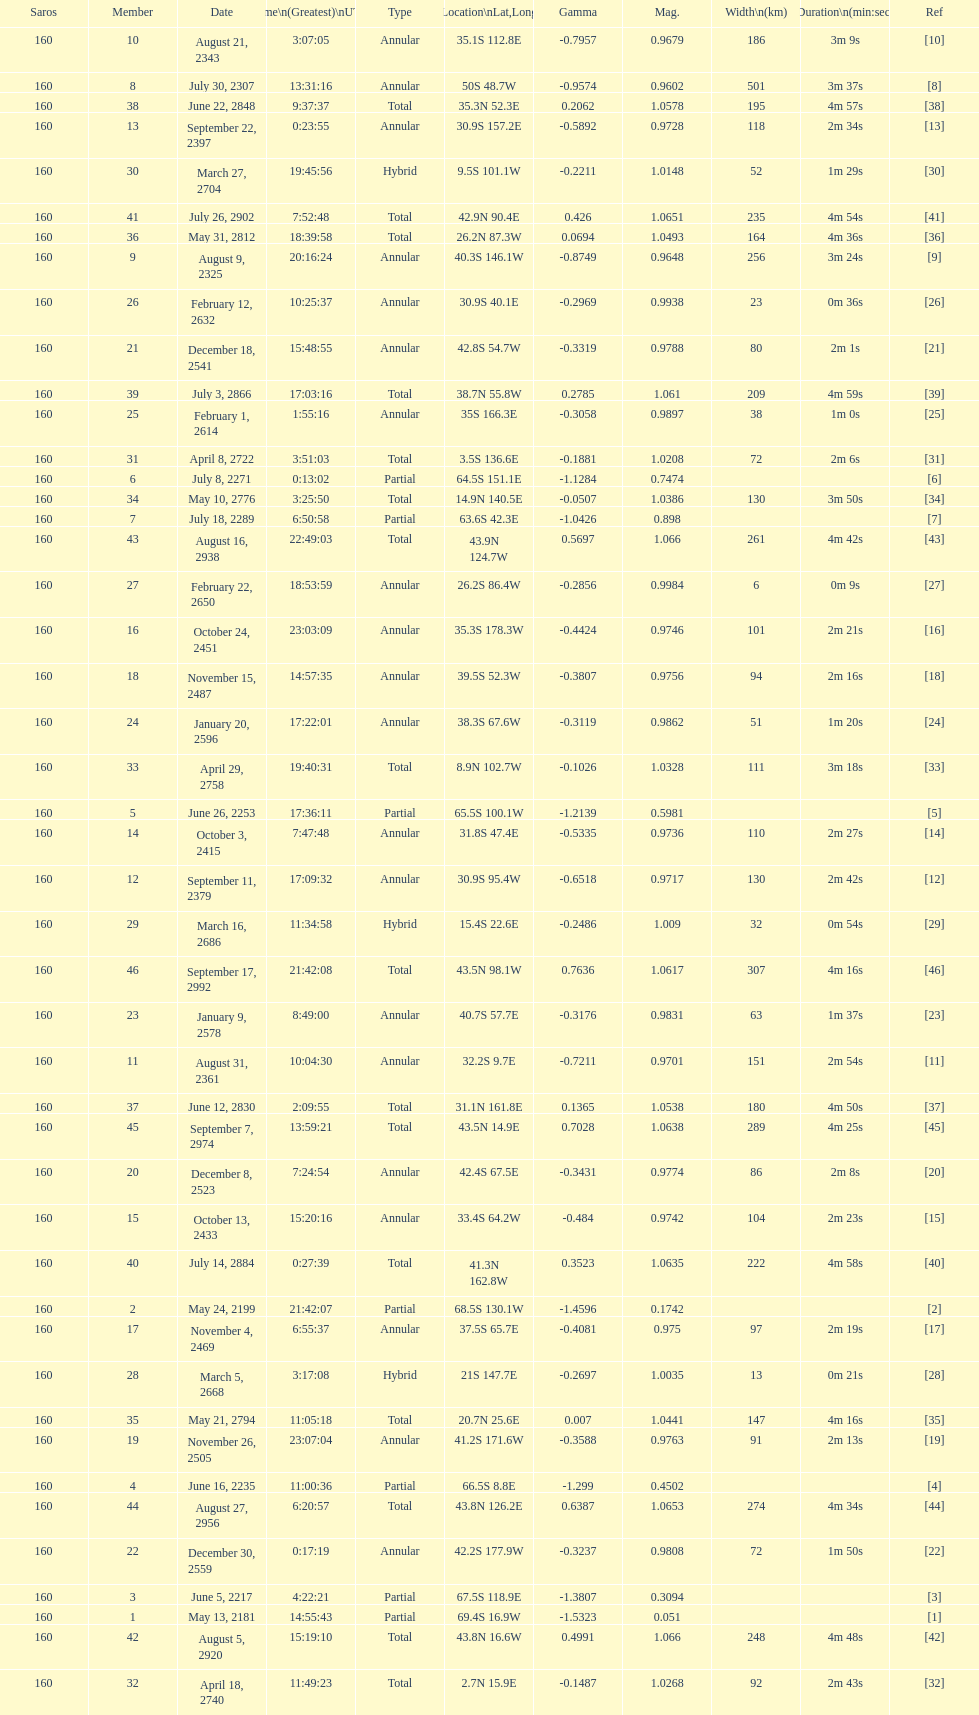What is the difference in magnitude between the may 13, 2181 solar saros and the may 24, 2199 solar saros? 0.1232. 